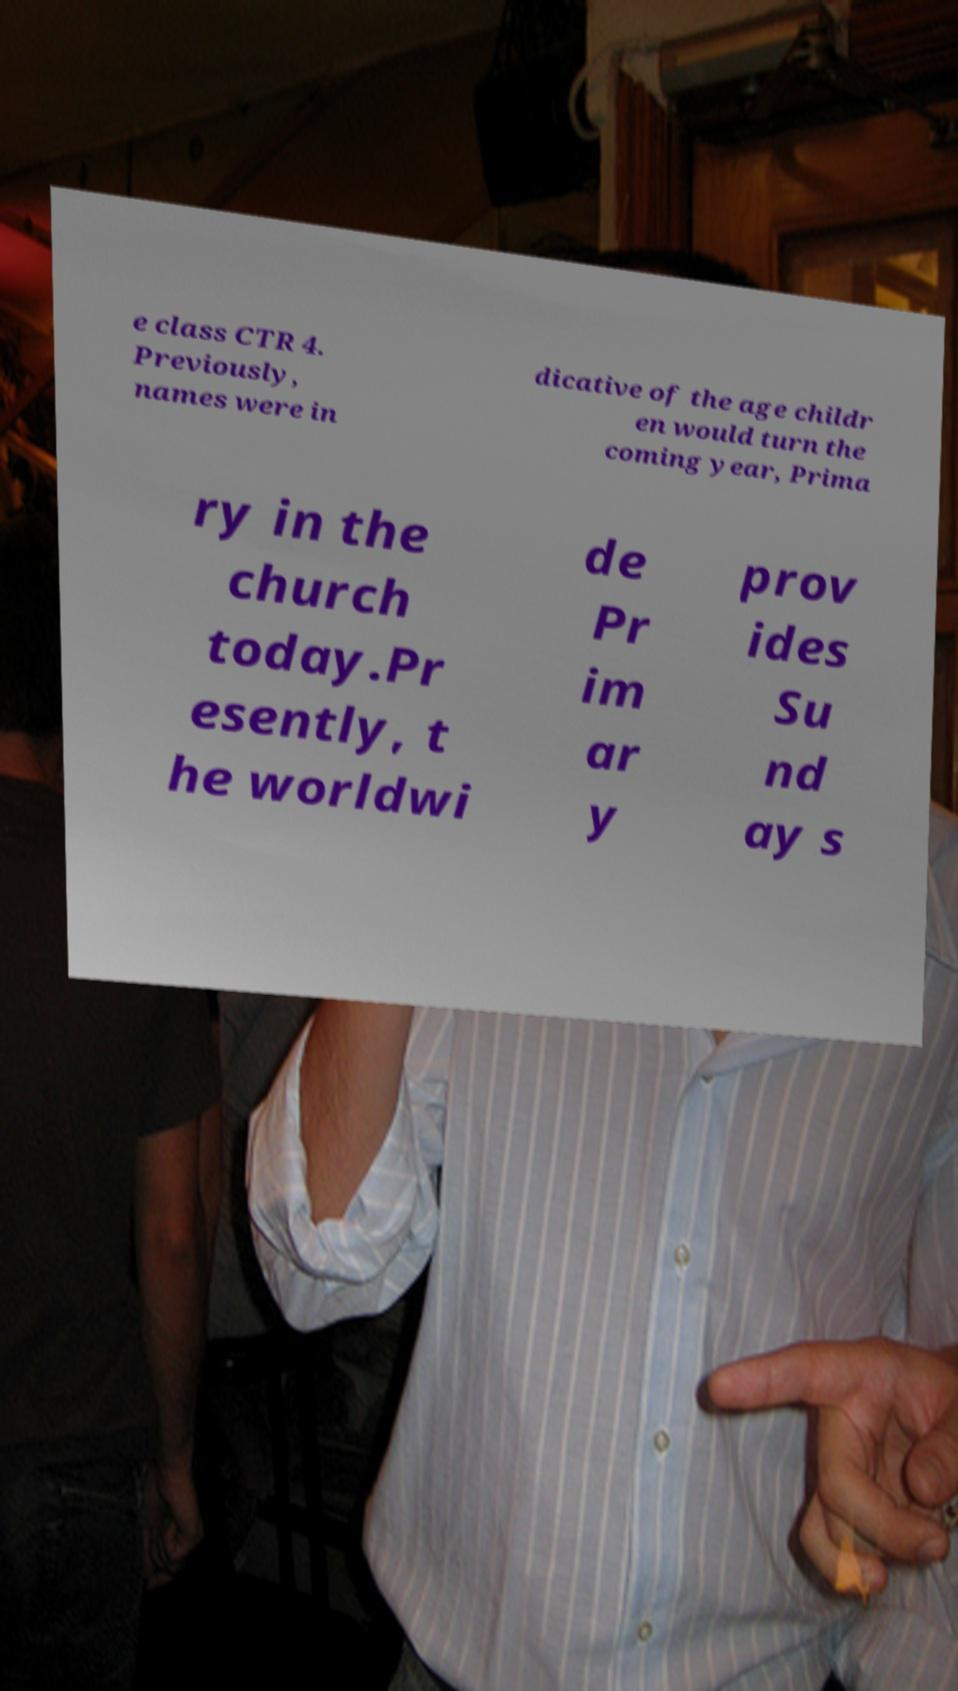Could you extract and type out the text from this image? e class CTR 4. Previously, names were in dicative of the age childr en would turn the coming year, Prima ry in the church today.Pr esently, t he worldwi de Pr im ar y prov ides Su nd ay s 